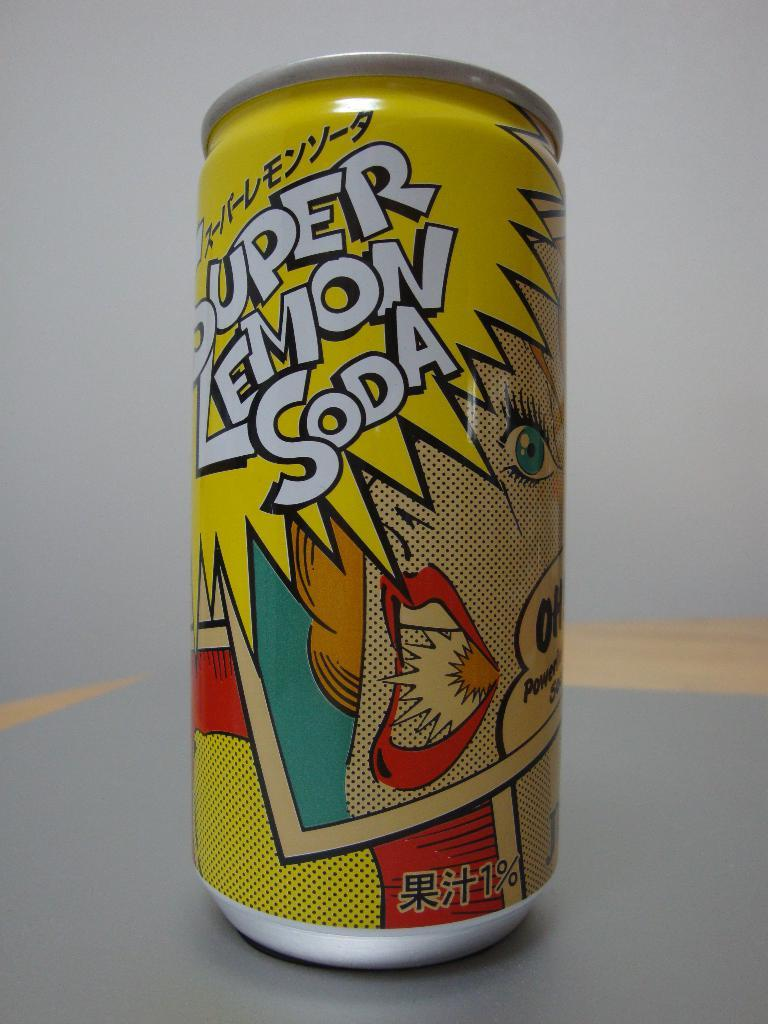Provide a one-sentence caption for the provided image. a can that has super lemon soda written on it. 